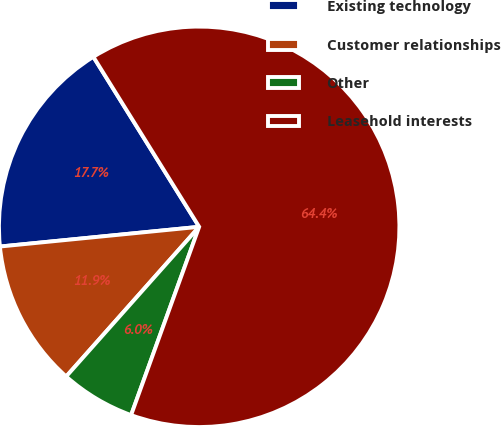Convert chart to OTSL. <chart><loc_0><loc_0><loc_500><loc_500><pie_chart><fcel>Existing technology<fcel>Customer relationships<fcel>Other<fcel>Leasehold interests<nl><fcel>17.71%<fcel>11.87%<fcel>6.04%<fcel>64.39%<nl></chart> 